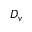<formula> <loc_0><loc_0><loc_500><loc_500>D _ { v }</formula> 